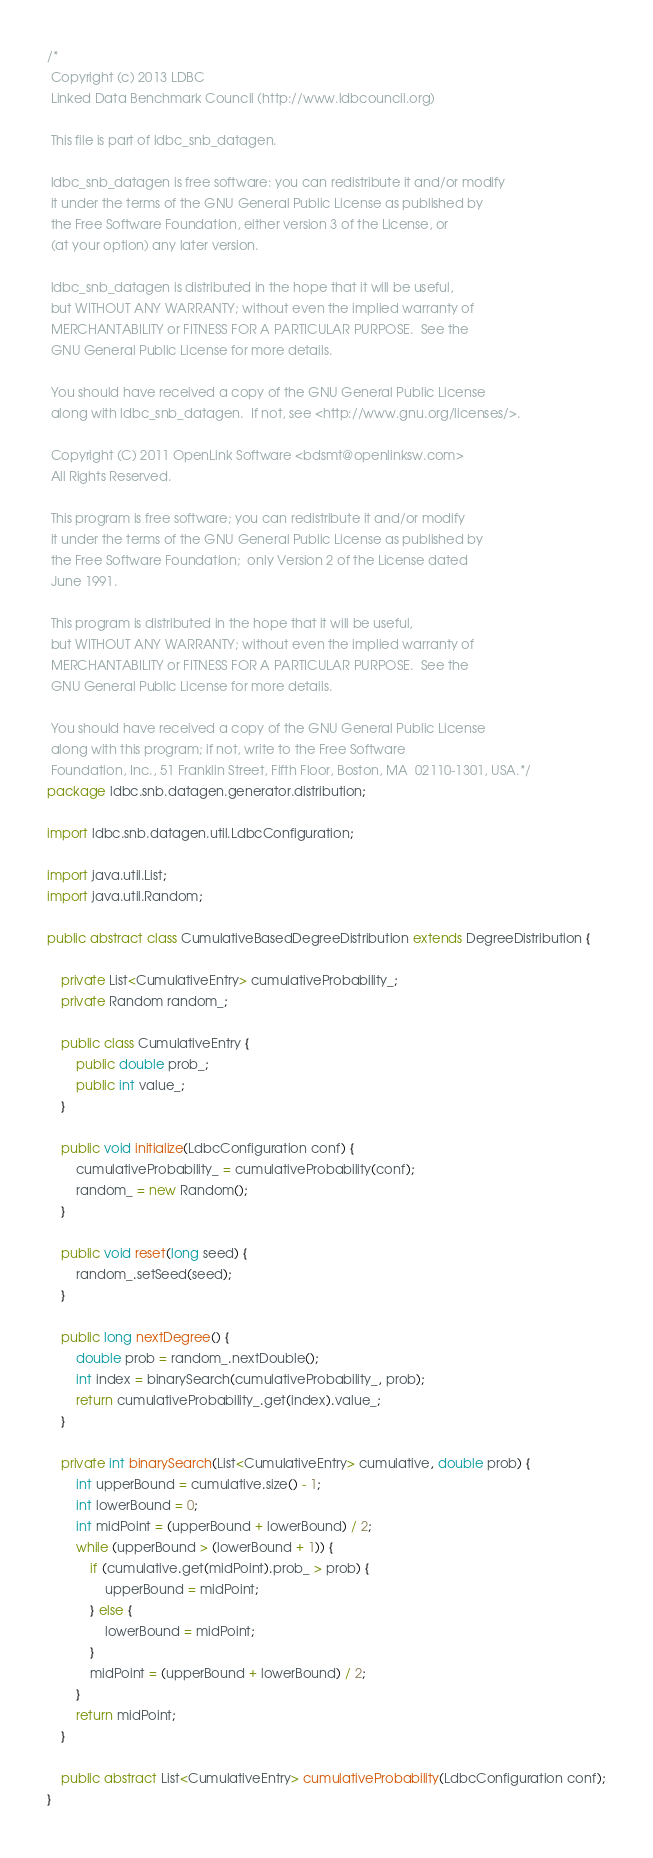<code> <loc_0><loc_0><loc_500><loc_500><_Java_>/* 
 Copyright (c) 2013 LDBC
 Linked Data Benchmark Council (http://www.ldbcouncil.org)
 
 This file is part of ldbc_snb_datagen.
 
 ldbc_snb_datagen is free software: you can redistribute it and/or modify
 it under the terms of the GNU General Public License as published by
 the Free Software Foundation, either version 3 of the License, or
 (at your option) any later version.
 
 ldbc_snb_datagen is distributed in the hope that it will be useful,
 but WITHOUT ANY WARRANTY; without even the implied warranty of
 MERCHANTABILITY or FITNESS FOR A PARTICULAR PURPOSE.  See the
 GNU General Public License for more details.
 
 You should have received a copy of the GNU General Public License
 along with ldbc_snb_datagen.  If not, see <http://www.gnu.org/licenses/>.
 
 Copyright (C) 2011 OpenLink Software <bdsmt@openlinksw.com>
 All Rights Reserved.
 
 This program is free software; you can redistribute it and/or modify
 it under the terms of the GNU General Public License as published by
 the Free Software Foundation;  only Version 2 of the License dated
 June 1991.
 
 This program is distributed in the hope that it will be useful,
 but WITHOUT ANY WARRANTY; without even the implied warranty of
 MERCHANTABILITY or FITNESS FOR A PARTICULAR PURPOSE.  See the
 GNU General Public License for more details.
 
 You should have received a copy of the GNU General Public License
 along with this program; if not, write to the Free Software
 Foundation, Inc., 51 Franklin Street, Fifth Floor, Boston, MA  02110-1301, USA.*/
package ldbc.snb.datagen.generator.distribution;

import ldbc.snb.datagen.util.LdbcConfiguration;

import java.util.List;
import java.util.Random;

public abstract class CumulativeBasedDegreeDistribution extends DegreeDistribution {

    private List<CumulativeEntry> cumulativeProbability_;
    private Random random_;

    public class CumulativeEntry {
        public double prob_;
        public int value_;
    }

    public void initialize(LdbcConfiguration conf) {
        cumulativeProbability_ = cumulativeProbability(conf);
        random_ = new Random();
    }

    public void reset(long seed) {
        random_.setSeed(seed);
    }

    public long nextDegree() {
        double prob = random_.nextDouble();
        int index = binarySearch(cumulativeProbability_, prob);
        return cumulativeProbability_.get(index).value_;
    }

    private int binarySearch(List<CumulativeEntry> cumulative, double prob) {
        int upperBound = cumulative.size() - 1;
        int lowerBound = 0;
        int midPoint = (upperBound + lowerBound) / 2;
        while (upperBound > (lowerBound + 1)) {
            if (cumulative.get(midPoint).prob_ > prob) {
                upperBound = midPoint;
            } else {
                lowerBound = midPoint;
            }
            midPoint = (upperBound + lowerBound) / 2;
        }
        return midPoint;
    }

    public abstract List<CumulativeEntry> cumulativeProbability(LdbcConfiguration conf);
}
</code> 